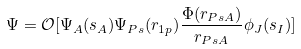<formula> <loc_0><loc_0><loc_500><loc_500>\Psi = \mathcal { O } [ \Psi _ { A } ( s _ { A } ) \Psi _ { P s } ( r _ { 1 p } ) \frac { \Phi ( r _ { P s A } ) } { r _ { P s A } } \phi _ { J } ( s _ { I } ) ]</formula> 